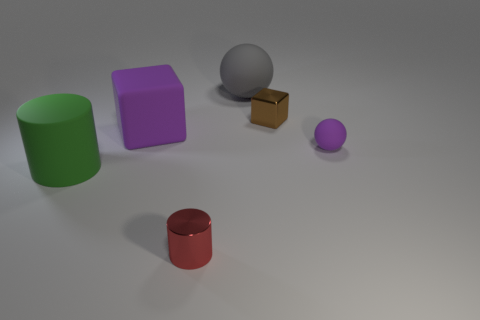Are there any cyan balls that have the same material as the gray object?
Provide a succinct answer. No. There is a cylinder on the right side of the rubber thing in front of the tiny purple rubber ball; is there a small shiny object that is behind it?
Offer a terse response. Yes. What is the shape of the red object that is the same size as the purple matte ball?
Your response must be concise. Cylinder. There is a metallic object that is right of the large sphere; does it have the same size as the purple thing that is to the right of the tiny brown shiny thing?
Give a very brief answer. Yes. How many tiny green cylinders are there?
Provide a succinct answer. 0. What size is the purple object to the right of the big rubber object to the right of the shiny cylinder that is in front of the gray thing?
Provide a succinct answer. Small. Is the color of the tiny matte object the same as the rubber cube?
Provide a succinct answer. Yes. There is a metallic cube; what number of matte balls are to the left of it?
Provide a short and direct response. 1. Are there the same number of large green cylinders behind the big green matte cylinder and tiny cyan metallic cylinders?
Offer a very short reply. Yes. How many things are either small blue shiny objects or small metal objects?
Your answer should be very brief. 2. 